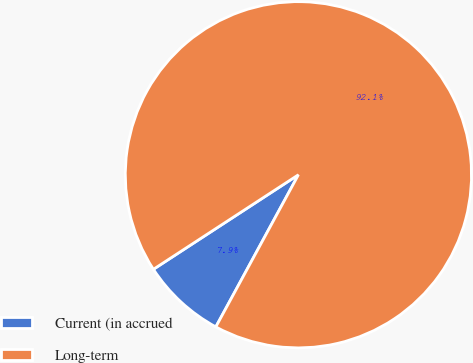<chart> <loc_0><loc_0><loc_500><loc_500><pie_chart><fcel>Current (in accrued<fcel>Long-term<nl><fcel>7.89%<fcel>92.11%<nl></chart> 